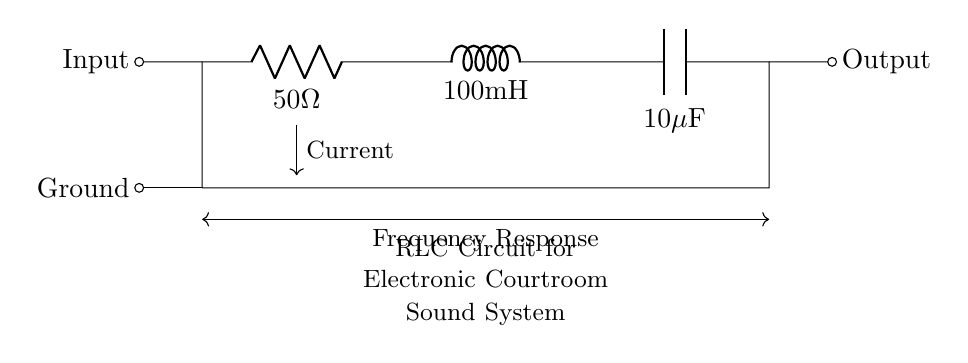What is the resistance value in the circuit? The resistance value is denoted by R in the circuit diagram. It is explicitly labeled as "50 Ohm."
Answer: 50 Ohm What is the inductance value in the circuit? The inductance value is represented by L in the circuit diagram. It is directly labeled as "100 mH."
Answer: 100 mH What is the capacitance value in this circuit? The capacitance value is indicated by C in the circuit diagram. It is labeled as "10 microfarad."
Answer: 10 microfarad What is the role of the resistor in this circuit? The resistor regulates current flow and limits the amount of current that can pass through the circuit. It is necessary for protecting other components from excess current.
Answer: Current limiter How does the RLC circuit affect sound quality in a courtroom? The RLC circuit creates a particular frequency response that selectively enhances certain frequencies, which can significantly improve sound clarity and intelligibility in a courtroom setting.
Answer: Enhances sound clarity What occurs when the frequency increases in this RLC circuit? As frequency increases, the inductive reactance increases while capacitive reactance decreases. This alters the impedance and can change how signals are processed, potentially affecting sound quality.
Answer: Impedance change What happens to the output when the input is inconsistent? An inconsistent input can cause distortion in the output, potentially leading to unclear or unintelligible sound during proceedings since the RLC circuit will not properly filter out unwanted frequencies.
Answer: Output distortion 